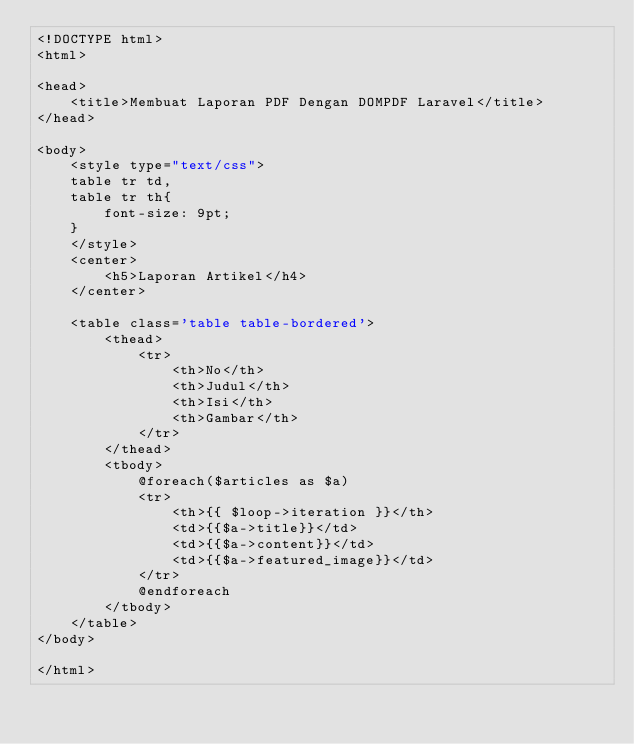<code> <loc_0><loc_0><loc_500><loc_500><_PHP_><!DOCTYPE html>
<html>

<head>
    <title>Membuat Laporan PDF Dengan DOMPDF Laravel</title>
</head>

<body>
    <style type="text/css"> 
    table tr td, 
    table tr th{
        font-size: 9pt;
    }
    </style>
    <center>
        <h5>Laporan Artikel</h4>
    </center>

    <table class='table table-bordered'>
        <thead>
            <tr>
                <th>No</th>
                <th>Judul</th>
                <th>Isi</th>
                <th>Gambar</th>
            </tr>
        </thead>
        <tbody>
            @foreach($articles as $a)
            <tr>
                <th>{{ $loop->iteration }}</th>
                <td>{{$a->title}}</td>
                <td>{{$a->content}}</td>
                <td>{{$a->featured_image}}</td>
            </tr>
            @endforeach
        </tbody>
    </table>
</body>

</html></code> 